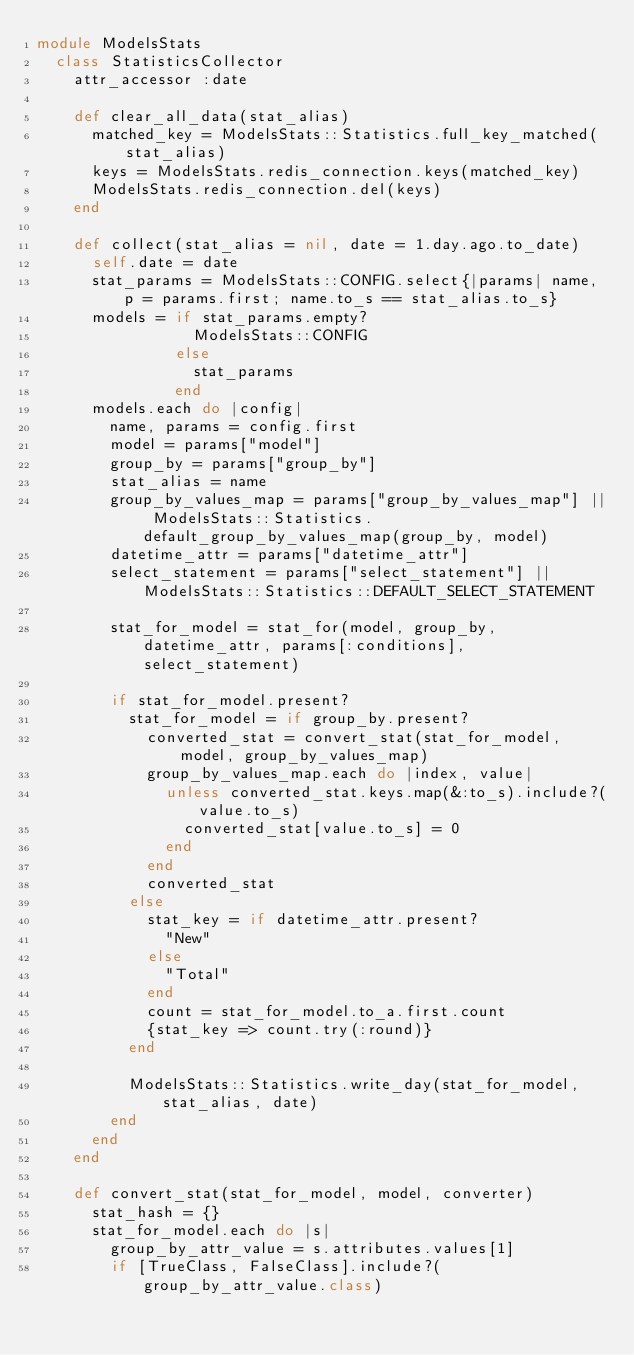<code> <loc_0><loc_0><loc_500><loc_500><_Ruby_>module ModelsStats
  class StatisticsCollector
    attr_accessor :date

    def clear_all_data(stat_alias)
      matched_key = ModelsStats::Statistics.full_key_matched(stat_alias)
      keys = ModelsStats.redis_connection.keys(matched_key)
      ModelsStats.redis_connection.del(keys)
    end

    def collect(stat_alias = nil, date = 1.day.ago.to_date)
      self.date = date
      stat_params = ModelsStats::CONFIG.select{|params| name, p = params.first; name.to_s == stat_alias.to_s}
      models = if stat_params.empty?
                 ModelsStats::CONFIG
               else
                 stat_params
               end
      models.each do |config|
        name, params = config.first
        model = params["model"]
        group_by = params["group_by"]
        stat_alias = name
        group_by_values_map = params["group_by_values_map"] || ModelsStats::Statistics.default_group_by_values_map(group_by, model)
        datetime_attr = params["datetime_attr"]
        select_statement = params["select_statement"] || ModelsStats::Statistics::DEFAULT_SELECT_STATEMENT

        stat_for_model = stat_for(model, group_by, datetime_attr, params[:conditions], select_statement)

        if stat_for_model.present?
          stat_for_model = if group_by.present?
            converted_stat = convert_stat(stat_for_model, model, group_by_values_map)
            group_by_values_map.each do |index, value|
              unless converted_stat.keys.map(&:to_s).include?(value.to_s)
                converted_stat[value.to_s] = 0
              end
            end
            converted_stat
          else
            stat_key = if datetime_attr.present?
              "New"
            else
              "Total"
            end
            count = stat_for_model.to_a.first.count
            {stat_key => count.try(:round)}
          end

          ModelsStats::Statistics.write_day(stat_for_model, stat_alias, date)
        end
      end
    end

    def convert_stat(stat_for_model, model, converter)
      stat_hash = {}
      stat_for_model.each do |s|
        group_by_attr_value = s.attributes.values[1]
        if [TrueClass, FalseClass].include?(group_by_attr_value.class)</code> 